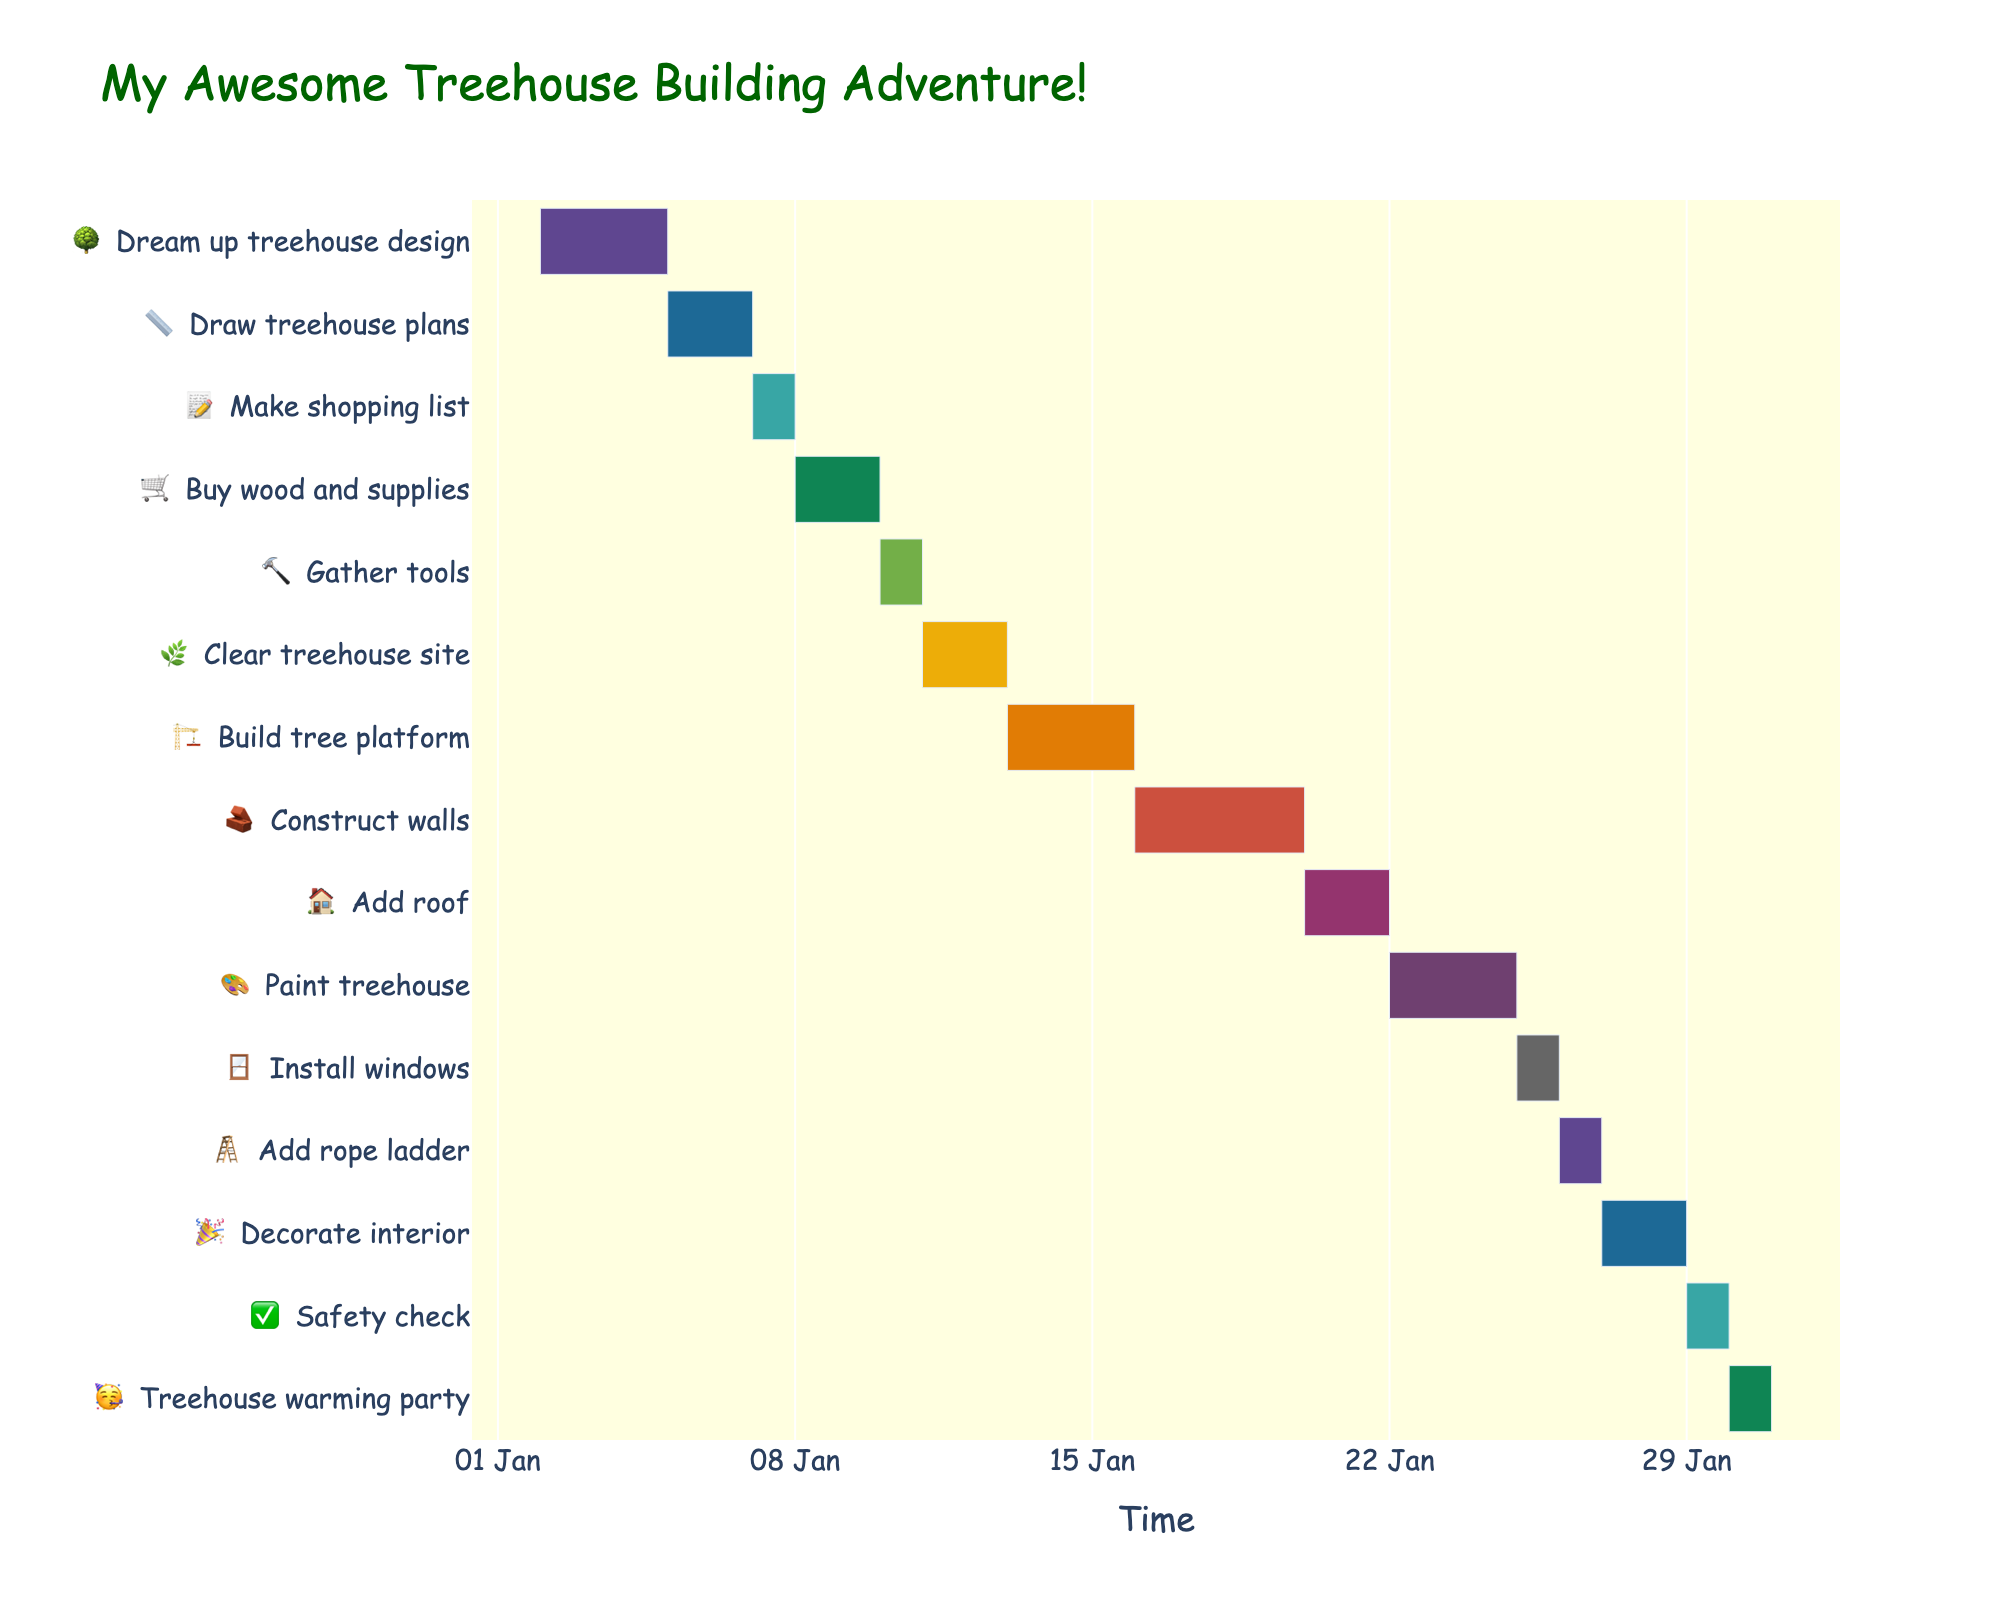What is the title of the Gantt Chart? The title of the Gantt Chart appears at the top of the chart in a larger font size and unique color.
Answer: My Awesome Treehouse Building Adventure! When does the "Dream up treehouse design" task start? Locate the "Dream up treehouse design" task on the y-axis, then note the start date shown on the x-axis.
Answer: Jan 2 What is the duration of the "Construct walls" task? Find the "Construct walls" task on the y-axis and look at the length of the bar, or check the hover information for its duration.
Answer: 4 days Which task has the shortest duration? Identify the tasks by their bars' lengths or look at the hover information for each task's duration. The shortest bar corresponds to the shortest task.
Answer: Gather tools, Make shopping list, Install windows, and Add rope ladder (all 1 day) What tasks are scheduled to start exactly after "Buy wood and supplies" ends? Identify the end date of the "Buy wood and supplies" task by looking at the bar's end point on the x-axis, then find tasks that start right after that end date.
Answer: Gather tools When is the "Treehouse warming party" scheduled? Find the "Treehouse warming party" task on the y-axis and note its start date and duration on the x-axis.
Answer: Jan 30 How many tasks are involved in the planning phase? Count the tasks listed in the planning phase, which typically include design conceptualization and initial preparations before actual construction.
Answer: 3 (Dream up treehouse design, Draw treehouse plans, Make shopping list) What is the overall duration from the start of the first task to the end of the last task? Find the start date of the first task at the top and end date of the last task at the bottom, then calculate the difference between these dates.
Answer: 29 days Which task has the longest duration, and how long is it? Evaluate the lengths of all bars or hover over each to find the one with the longest duration.
Answer: Construct walls, 4 days Are there any tasks that overlap completely in their schedule? Look for bars that fully overlap in the timeline; they should cover the same dates.
Answer: Construct walls and Add roof 